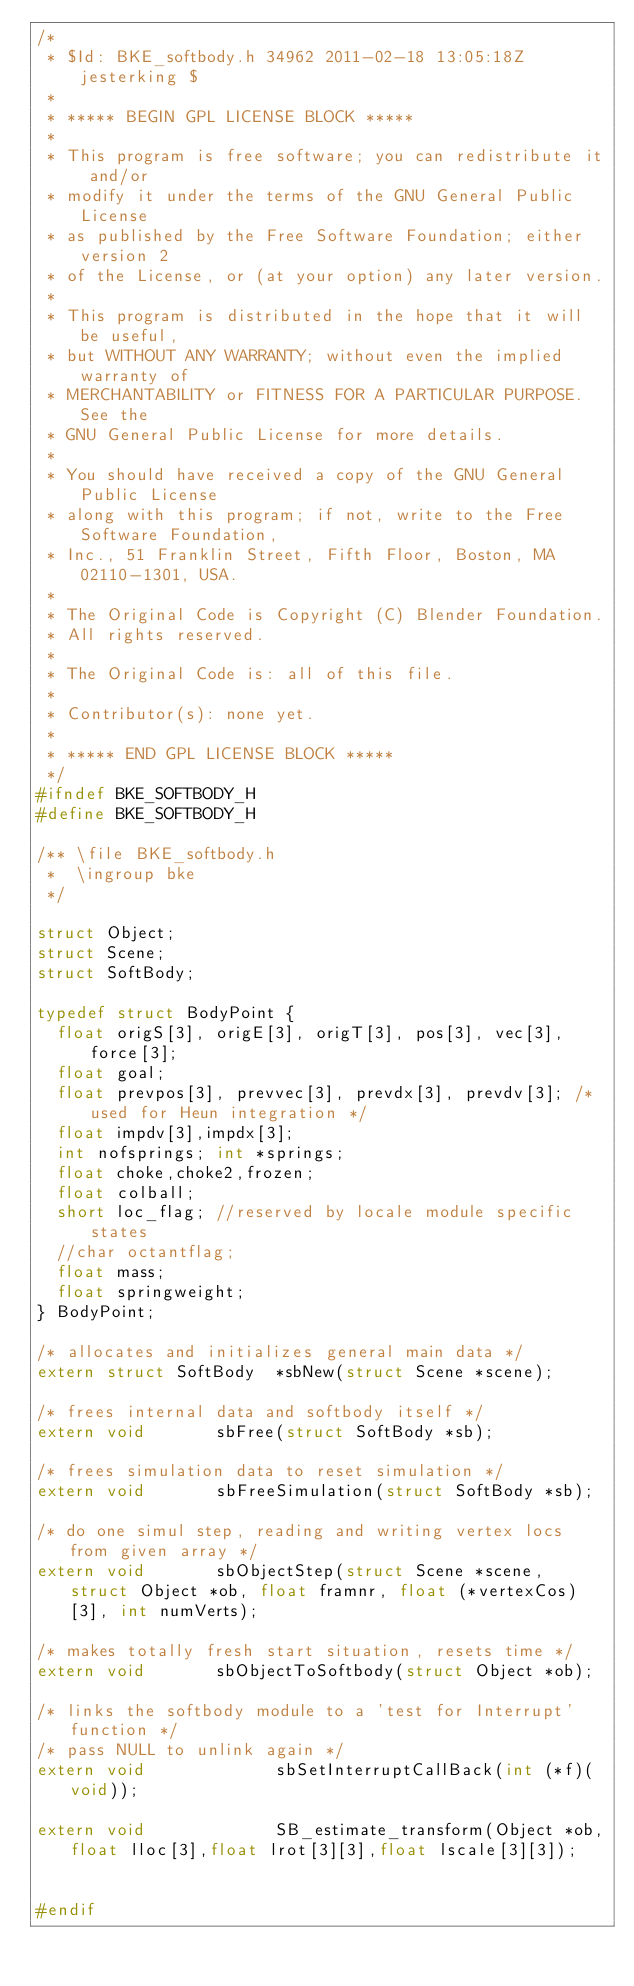<code> <loc_0><loc_0><loc_500><loc_500><_C_>/*
 * $Id: BKE_softbody.h 34962 2011-02-18 13:05:18Z jesterking $
 *
 * ***** BEGIN GPL LICENSE BLOCK *****
 *
 * This program is free software; you can redistribute it and/or
 * modify it under the terms of the GNU General Public License
 * as published by the Free Software Foundation; either version 2
 * of the License, or (at your option) any later version.
 *
 * This program is distributed in the hope that it will be useful,
 * but WITHOUT ANY WARRANTY; without even the implied warranty of
 * MERCHANTABILITY or FITNESS FOR A PARTICULAR PURPOSE.  See the
 * GNU General Public License for more details.
 *
 * You should have received a copy of the GNU General Public License
 * along with this program; if not, write to the Free Software Foundation,
 * Inc., 51 Franklin Street, Fifth Floor, Boston, MA 02110-1301, USA.
 *
 * The Original Code is Copyright (C) Blender Foundation.
 * All rights reserved.
 *
 * The Original Code is: all of this file.
 *
 * Contributor(s): none yet.
 *
 * ***** END GPL LICENSE BLOCK *****
 */
#ifndef BKE_SOFTBODY_H
#define BKE_SOFTBODY_H

/** \file BKE_softbody.h
 *  \ingroup bke
 */

struct Object;
struct Scene;
struct SoftBody;

typedef struct BodyPoint {
	float origS[3], origE[3], origT[3], pos[3], vec[3], force[3];
	float goal;
	float prevpos[3], prevvec[3], prevdx[3], prevdv[3]; /* used for Heun integration */
	float impdv[3],impdx[3];
	int nofsprings; int *springs;
	float choke,choke2,frozen;
	float colball;
	short loc_flag; //reserved by locale module specific states
	//char octantflag;
	float mass;
	float springweight;
} BodyPoint;

/* allocates and initializes general main data */
extern struct SoftBody	*sbNew(struct Scene *scene);

/* frees internal data and softbody itself */
extern void				sbFree(struct SoftBody *sb);

/* frees simulation data to reset simulation */
extern void				sbFreeSimulation(struct SoftBody *sb);

/* do one simul step, reading and writing vertex locs from given array */
extern void				sbObjectStep(struct Scene *scene, struct Object *ob, float framnr, float (*vertexCos)[3], int numVerts);

/* makes totally fresh start situation, resets time */
extern void				sbObjectToSoftbody(struct Object *ob);

/* links the softbody module to a 'test for Interrupt' function */
/* pass NULL to unlink again */
extern void             sbSetInterruptCallBack(int (*f)(void));

extern void             SB_estimate_transform(Object *ob,float lloc[3],float lrot[3][3],float lscale[3][3]);


#endif

</code> 